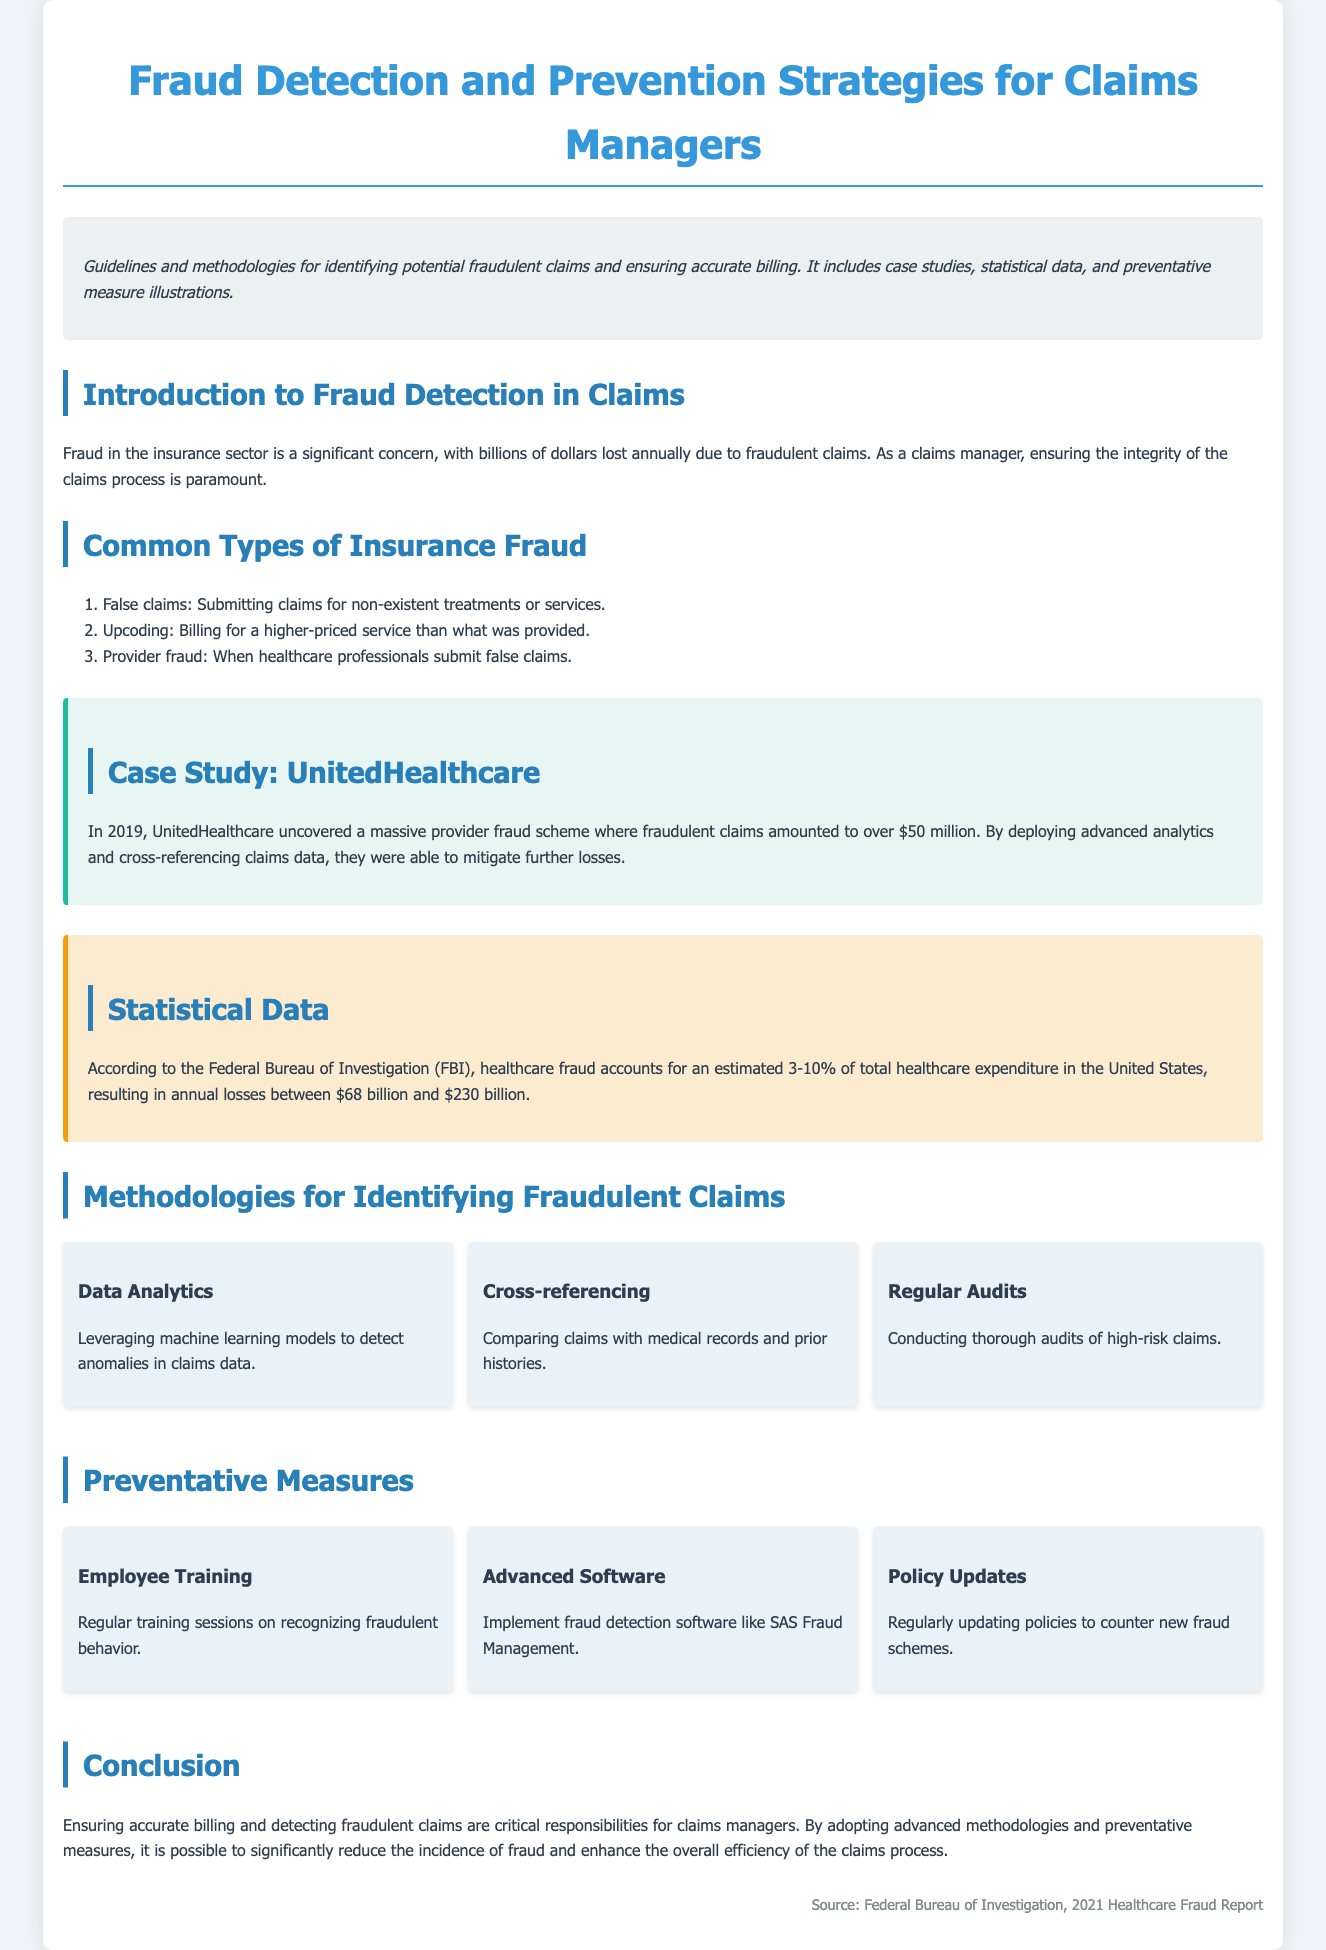What is the title of the document? The title is prominently displayed at the top of the document.
Answer: Fraud Detection and Prevention Strategies for Claims Managers What year did the UnitedHealthcare fraud scheme occur? The document includes a specific date when the case study took place.
Answer: 2019 According to the FBI, what percentage of total healthcare expenditure is attributed to healthcare fraud? This information is provided in the statistical data section.
Answer: 3-10% What is one method for identifying fraudulent claims mentioned in the document? The document lists various methodologies under the relevant section.
Answer: Data Analytics What software is suggested for fraud detection? The document mentions a specific software tool in the preventative measures section.
Answer: SAS Fraud Management How much loss is estimated annually due to healthcare fraud? The FBI's report gives a range for annual losses in the statistical data section.
Answer: Between $68 billion and $230 billion What is a common type of insurance fraud listed in the document? This information can be found in the section discussing common types of insurance fraud.
Answer: False claims What is a suggested preventative measure for claims managers? The document offers several measures to prevent fraud, listed clearly.
Answer: Employee Training 